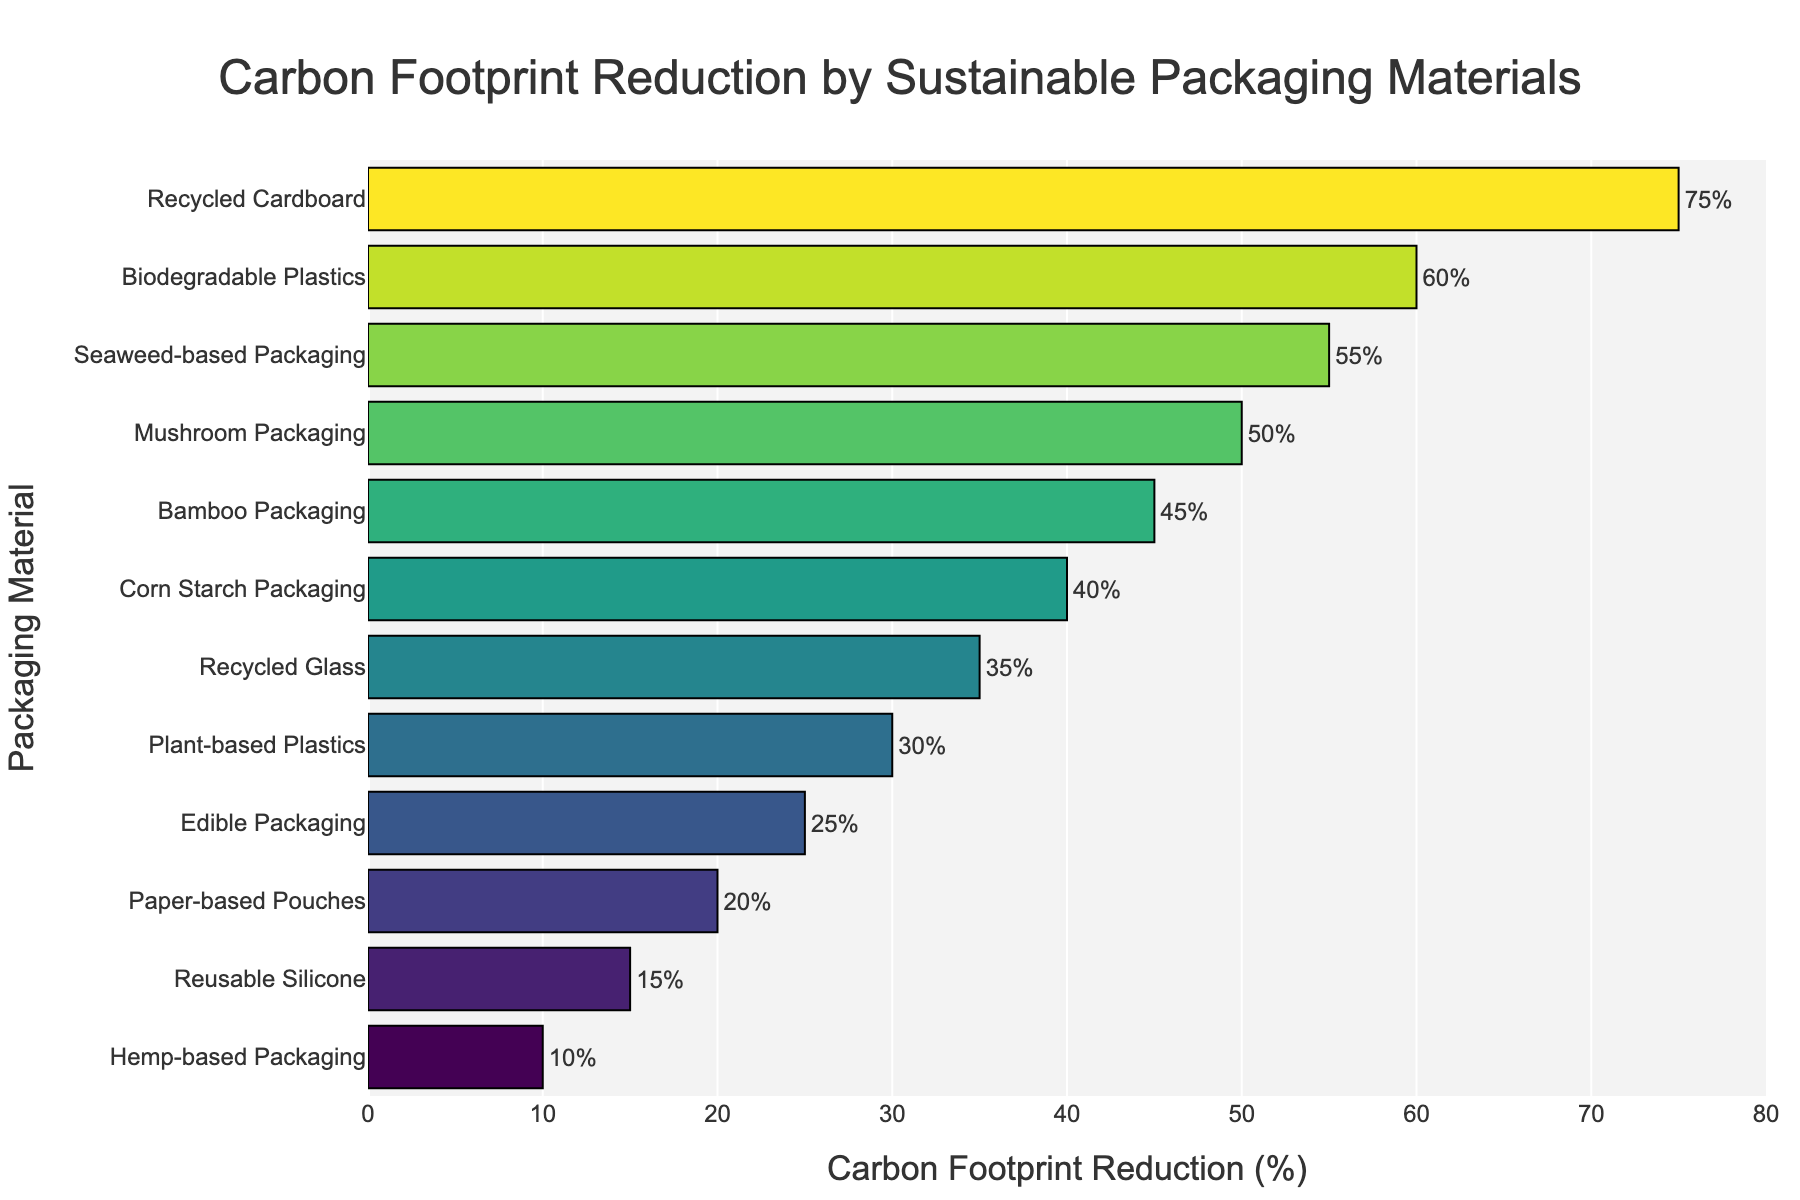Which material achieves the highest carbon footprint reduction? The material with the highest carbon footprint reduction percentage has the longest bar.
Answer: Recycled Cardboard Which material has the lowest carbon footprint reduction? The material with the smallest carbon footprint reduction percentage has the shortest bar.
Answer: Hemp-based Packaging What is the difference in carbon footprint reduction between Recycled Cardboard and Edible Packaging? Subtract the carbon footprint reduction percentage of Edible Packaging (25%) from that of Recycled Cardboard (75%).
Answer: 50% Which materials have a carbon footprint reduction of at least 50%? Identify the materials where the bar extends to at least the 50% mark on the x-axis.
Answer: Recycled Cardboard, Biodegradable Plastics, Seaweed-based Packaging, Mushroom Packaging How much greater is the carbon footprint reduction of Seaweed-based Packaging compared to Plant-based Plastics? Subtract the carbon footprint reduction percentage of Plant-based Plastics (30%) from that of Seaweed-based Packaging (55%).
Answer: 25% What is the average carbon footprint reduction across all materials? Sum the carbon footprint reduction percentages of all materials and divide by the number of materials (12). Calculation: (75 + 60 + 55 + 50 + 45 + 40 + 35 + 30 + 25 + 20 + 15 + 10) / 12 = 38.75
Answer: 38.75% Which material achieves a 35% carbon footprint reduction? Identify the material where the bar extends to the 35% mark on the x-axis.
Answer: Recycled Glass Among the top 3 materials with the highest reduction, what is the range of their carbon footprint reduction percentages? Subtract the carbon footprint reduction percentage of the third material (Seaweed-based Packaging, 55%) from that of the first material (Recycled Cardboard, 75%).
Answer: 20% Which materials have a carbon footprint reduction between 30% and 50%? Identify the materials with bars extending between the 30% and 50% marks on the x-axis.
Answer: Mushroom Packaging, Bamboo Packaging, Corn Starch Packaging, Recycled Glass, Plant-based Plastics What is the median carbon footprint reduction percentage? Arrange the percentages in ascending order and find the middle value(s). If even, average the two middle values. Values: 10, 15, 20, 25, 30, 35, 40, 45, 50, 55, 60, 75. Median = (35 + 40) / 2 = 37.5
Answer: 37.5% 